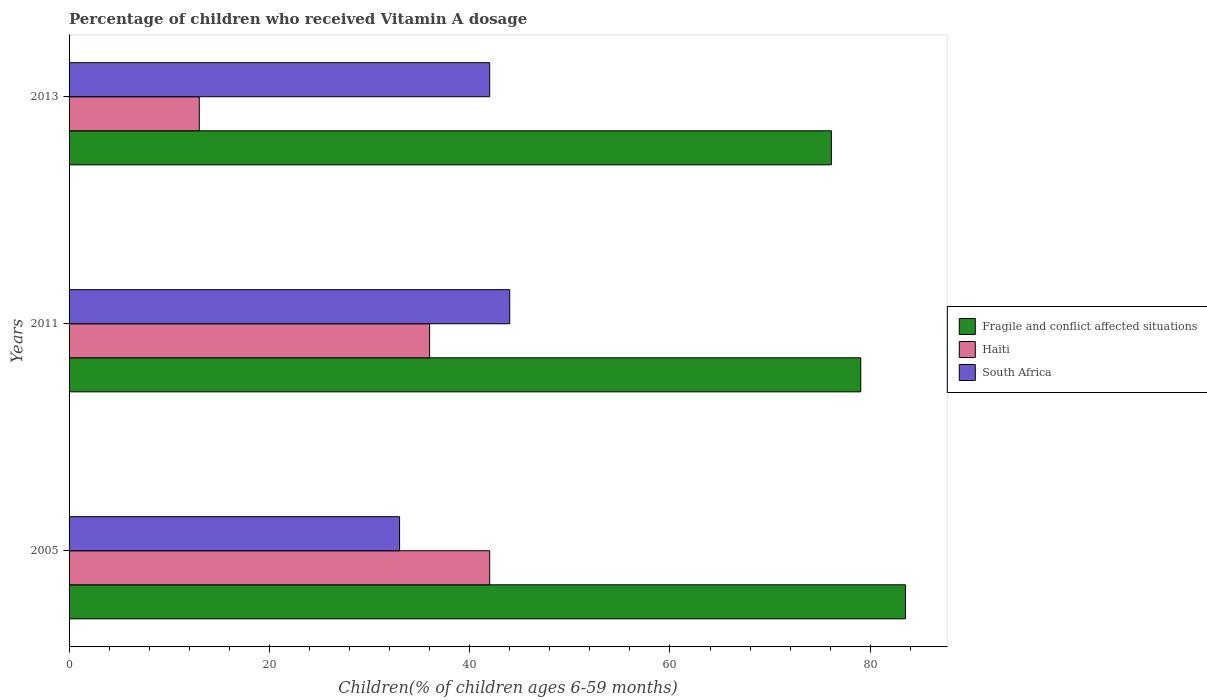Are the number of bars per tick equal to the number of legend labels?
Keep it short and to the point. Yes. Are the number of bars on each tick of the Y-axis equal?
Make the answer very short. Yes. How many bars are there on the 3rd tick from the top?
Keep it short and to the point. 3. How many bars are there on the 3rd tick from the bottom?
Your answer should be compact. 3. In how many cases, is the number of bars for a given year not equal to the number of legend labels?
Your response must be concise. 0. What is the percentage of children who received Vitamin A dosage in Haiti in 2011?
Provide a short and direct response. 36. Across all years, what is the maximum percentage of children who received Vitamin A dosage in Fragile and conflict affected situations?
Offer a very short reply. 83.51. Across all years, what is the minimum percentage of children who received Vitamin A dosage in Fragile and conflict affected situations?
Offer a very short reply. 76.11. In which year was the percentage of children who received Vitamin A dosage in South Africa maximum?
Your answer should be very brief. 2011. What is the total percentage of children who received Vitamin A dosage in Fragile and conflict affected situations in the graph?
Give a very brief answer. 238.67. What is the difference between the percentage of children who received Vitamin A dosage in Fragile and conflict affected situations in 2005 and that in 2011?
Make the answer very short. 4.46. What is the difference between the percentage of children who received Vitamin A dosage in Haiti in 2005 and the percentage of children who received Vitamin A dosage in South Africa in 2011?
Give a very brief answer. -2. What is the average percentage of children who received Vitamin A dosage in Haiti per year?
Provide a succinct answer. 30.33. In the year 2011, what is the difference between the percentage of children who received Vitamin A dosage in South Africa and percentage of children who received Vitamin A dosage in Fragile and conflict affected situations?
Make the answer very short. -35.05. In how many years, is the percentage of children who received Vitamin A dosage in Haiti greater than 52 %?
Offer a very short reply. 0. What is the ratio of the percentage of children who received Vitamin A dosage in Fragile and conflict affected situations in 2005 to that in 2011?
Keep it short and to the point. 1.06. What is the difference between the highest and the second highest percentage of children who received Vitamin A dosage in South Africa?
Offer a very short reply. 2. Is the sum of the percentage of children who received Vitamin A dosage in South Africa in 2005 and 2013 greater than the maximum percentage of children who received Vitamin A dosage in Fragile and conflict affected situations across all years?
Your answer should be very brief. No. What does the 3rd bar from the top in 2011 represents?
Provide a succinct answer. Fragile and conflict affected situations. What does the 2nd bar from the bottom in 2013 represents?
Provide a succinct answer. Haiti. Is it the case that in every year, the sum of the percentage of children who received Vitamin A dosage in South Africa and percentage of children who received Vitamin A dosage in Fragile and conflict affected situations is greater than the percentage of children who received Vitamin A dosage in Haiti?
Give a very brief answer. Yes. How many bars are there?
Offer a very short reply. 9. Are all the bars in the graph horizontal?
Provide a succinct answer. Yes. How many years are there in the graph?
Keep it short and to the point. 3. What is the difference between two consecutive major ticks on the X-axis?
Your response must be concise. 20. Does the graph contain grids?
Offer a very short reply. No. Where does the legend appear in the graph?
Your response must be concise. Center right. How many legend labels are there?
Offer a very short reply. 3. What is the title of the graph?
Provide a short and direct response. Percentage of children who received Vitamin A dosage. What is the label or title of the X-axis?
Your answer should be very brief. Children(% of children ages 6-59 months). What is the label or title of the Y-axis?
Provide a short and direct response. Years. What is the Children(% of children ages 6-59 months) of Fragile and conflict affected situations in 2005?
Give a very brief answer. 83.51. What is the Children(% of children ages 6-59 months) of Fragile and conflict affected situations in 2011?
Your response must be concise. 79.05. What is the Children(% of children ages 6-59 months) in Haiti in 2011?
Ensure brevity in your answer.  36. What is the Children(% of children ages 6-59 months) in Fragile and conflict affected situations in 2013?
Your answer should be compact. 76.11. What is the Children(% of children ages 6-59 months) in Haiti in 2013?
Ensure brevity in your answer.  13. What is the Children(% of children ages 6-59 months) of South Africa in 2013?
Give a very brief answer. 42. Across all years, what is the maximum Children(% of children ages 6-59 months) of Fragile and conflict affected situations?
Give a very brief answer. 83.51. Across all years, what is the maximum Children(% of children ages 6-59 months) in Haiti?
Keep it short and to the point. 42. Across all years, what is the minimum Children(% of children ages 6-59 months) of Fragile and conflict affected situations?
Keep it short and to the point. 76.11. Across all years, what is the minimum Children(% of children ages 6-59 months) in South Africa?
Offer a very short reply. 33. What is the total Children(% of children ages 6-59 months) in Fragile and conflict affected situations in the graph?
Ensure brevity in your answer.  238.67. What is the total Children(% of children ages 6-59 months) in Haiti in the graph?
Your answer should be compact. 91. What is the total Children(% of children ages 6-59 months) in South Africa in the graph?
Offer a terse response. 119. What is the difference between the Children(% of children ages 6-59 months) in Fragile and conflict affected situations in 2005 and that in 2011?
Your response must be concise. 4.46. What is the difference between the Children(% of children ages 6-59 months) in Haiti in 2005 and that in 2011?
Offer a terse response. 6. What is the difference between the Children(% of children ages 6-59 months) in South Africa in 2005 and that in 2011?
Your answer should be very brief. -11. What is the difference between the Children(% of children ages 6-59 months) of Fragile and conflict affected situations in 2005 and that in 2013?
Provide a succinct answer. 7.4. What is the difference between the Children(% of children ages 6-59 months) in Haiti in 2005 and that in 2013?
Keep it short and to the point. 29. What is the difference between the Children(% of children ages 6-59 months) in Fragile and conflict affected situations in 2011 and that in 2013?
Keep it short and to the point. 2.93. What is the difference between the Children(% of children ages 6-59 months) in South Africa in 2011 and that in 2013?
Ensure brevity in your answer.  2. What is the difference between the Children(% of children ages 6-59 months) in Fragile and conflict affected situations in 2005 and the Children(% of children ages 6-59 months) in Haiti in 2011?
Your response must be concise. 47.51. What is the difference between the Children(% of children ages 6-59 months) of Fragile and conflict affected situations in 2005 and the Children(% of children ages 6-59 months) of South Africa in 2011?
Your answer should be very brief. 39.51. What is the difference between the Children(% of children ages 6-59 months) of Haiti in 2005 and the Children(% of children ages 6-59 months) of South Africa in 2011?
Offer a very short reply. -2. What is the difference between the Children(% of children ages 6-59 months) in Fragile and conflict affected situations in 2005 and the Children(% of children ages 6-59 months) in Haiti in 2013?
Offer a terse response. 70.51. What is the difference between the Children(% of children ages 6-59 months) of Fragile and conflict affected situations in 2005 and the Children(% of children ages 6-59 months) of South Africa in 2013?
Keep it short and to the point. 41.51. What is the difference between the Children(% of children ages 6-59 months) in Fragile and conflict affected situations in 2011 and the Children(% of children ages 6-59 months) in Haiti in 2013?
Keep it short and to the point. 66.05. What is the difference between the Children(% of children ages 6-59 months) of Fragile and conflict affected situations in 2011 and the Children(% of children ages 6-59 months) of South Africa in 2013?
Offer a very short reply. 37.05. What is the difference between the Children(% of children ages 6-59 months) in Haiti in 2011 and the Children(% of children ages 6-59 months) in South Africa in 2013?
Your answer should be compact. -6. What is the average Children(% of children ages 6-59 months) in Fragile and conflict affected situations per year?
Your answer should be compact. 79.56. What is the average Children(% of children ages 6-59 months) in Haiti per year?
Your answer should be very brief. 30.33. What is the average Children(% of children ages 6-59 months) of South Africa per year?
Make the answer very short. 39.67. In the year 2005, what is the difference between the Children(% of children ages 6-59 months) in Fragile and conflict affected situations and Children(% of children ages 6-59 months) in Haiti?
Give a very brief answer. 41.51. In the year 2005, what is the difference between the Children(% of children ages 6-59 months) of Fragile and conflict affected situations and Children(% of children ages 6-59 months) of South Africa?
Give a very brief answer. 50.51. In the year 2005, what is the difference between the Children(% of children ages 6-59 months) in Haiti and Children(% of children ages 6-59 months) in South Africa?
Your response must be concise. 9. In the year 2011, what is the difference between the Children(% of children ages 6-59 months) of Fragile and conflict affected situations and Children(% of children ages 6-59 months) of Haiti?
Make the answer very short. 43.05. In the year 2011, what is the difference between the Children(% of children ages 6-59 months) in Fragile and conflict affected situations and Children(% of children ages 6-59 months) in South Africa?
Offer a very short reply. 35.05. In the year 2013, what is the difference between the Children(% of children ages 6-59 months) in Fragile and conflict affected situations and Children(% of children ages 6-59 months) in Haiti?
Make the answer very short. 63.11. In the year 2013, what is the difference between the Children(% of children ages 6-59 months) in Fragile and conflict affected situations and Children(% of children ages 6-59 months) in South Africa?
Give a very brief answer. 34.11. What is the ratio of the Children(% of children ages 6-59 months) of Fragile and conflict affected situations in 2005 to that in 2011?
Make the answer very short. 1.06. What is the ratio of the Children(% of children ages 6-59 months) in Haiti in 2005 to that in 2011?
Provide a succinct answer. 1.17. What is the ratio of the Children(% of children ages 6-59 months) of Fragile and conflict affected situations in 2005 to that in 2013?
Offer a very short reply. 1.1. What is the ratio of the Children(% of children ages 6-59 months) of Haiti in 2005 to that in 2013?
Your response must be concise. 3.23. What is the ratio of the Children(% of children ages 6-59 months) of South Africa in 2005 to that in 2013?
Give a very brief answer. 0.79. What is the ratio of the Children(% of children ages 6-59 months) in Fragile and conflict affected situations in 2011 to that in 2013?
Your response must be concise. 1.04. What is the ratio of the Children(% of children ages 6-59 months) of Haiti in 2011 to that in 2013?
Provide a short and direct response. 2.77. What is the ratio of the Children(% of children ages 6-59 months) in South Africa in 2011 to that in 2013?
Ensure brevity in your answer.  1.05. What is the difference between the highest and the second highest Children(% of children ages 6-59 months) in Fragile and conflict affected situations?
Provide a short and direct response. 4.46. What is the difference between the highest and the second highest Children(% of children ages 6-59 months) of South Africa?
Your answer should be compact. 2. What is the difference between the highest and the lowest Children(% of children ages 6-59 months) in Fragile and conflict affected situations?
Provide a short and direct response. 7.4. What is the difference between the highest and the lowest Children(% of children ages 6-59 months) of Haiti?
Your answer should be very brief. 29. What is the difference between the highest and the lowest Children(% of children ages 6-59 months) in South Africa?
Your answer should be very brief. 11. 